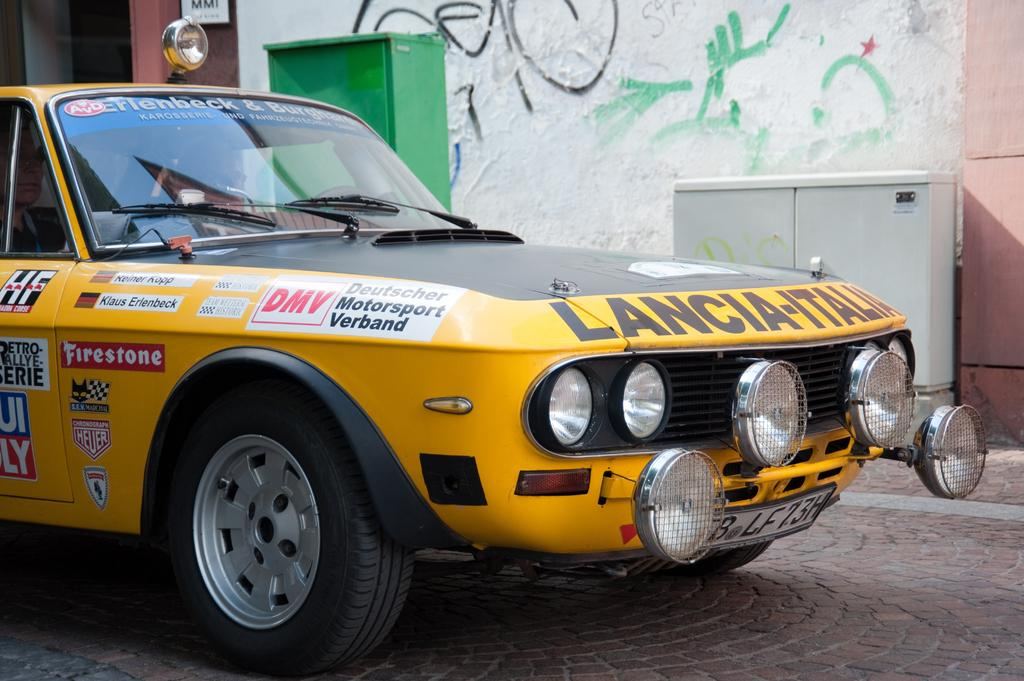What is the main subject of the image? There is a car in the image. What can be seen behind the car? There are objects behind the car. What is located behind the objects? There is a wall behind the objects. What is written on the wall? There are different writings on the wall. What type of iron can be seen in the image? There is no iron present in the image. What is the opinion of the machine in the image? There is no machine present in the image, so it is not possible to determine its opinion. 